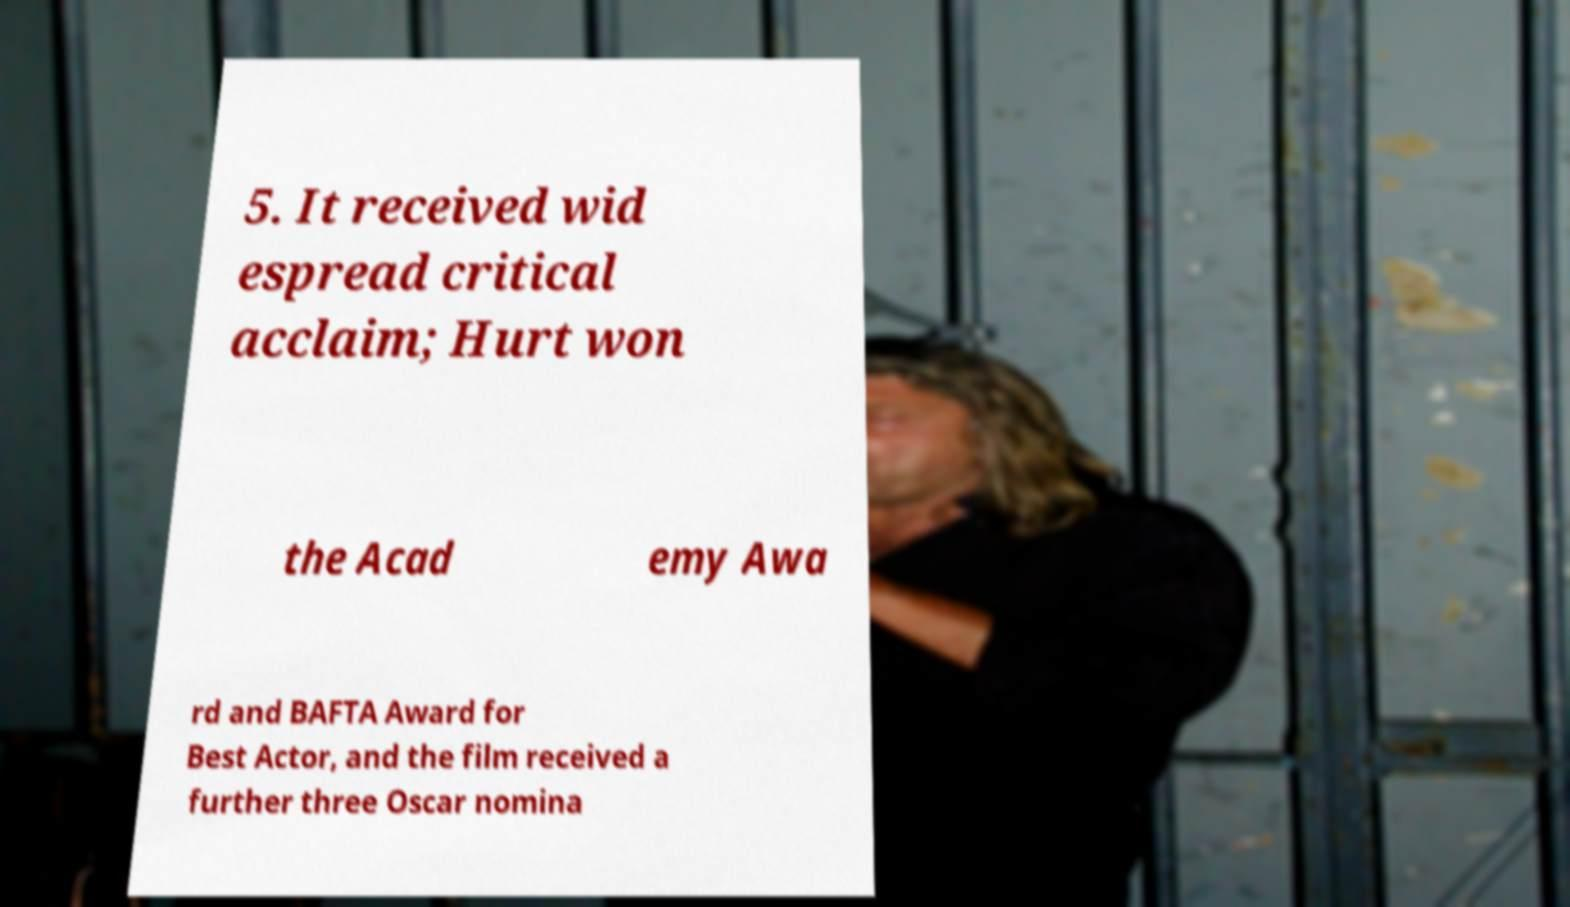What messages or text are displayed in this image? I need them in a readable, typed format. 5. It received wid espread critical acclaim; Hurt won the Acad emy Awa rd and BAFTA Award for Best Actor, and the film received a further three Oscar nomina 